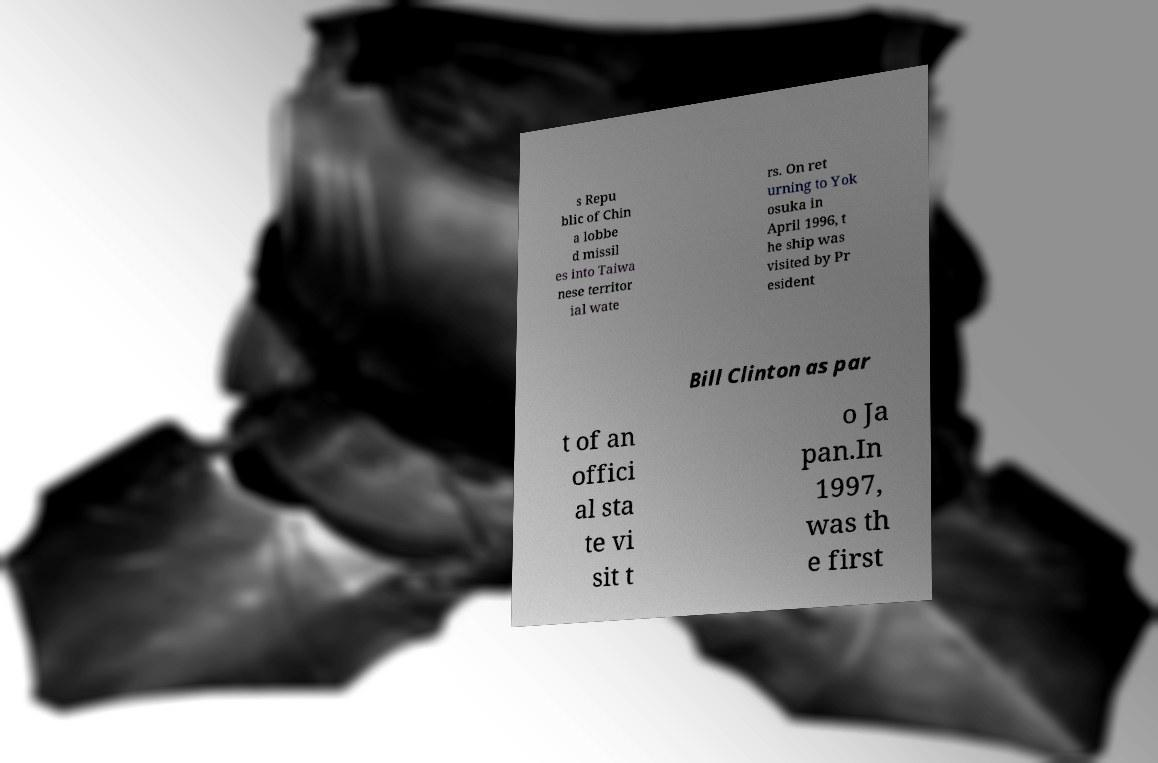For documentation purposes, I need the text within this image transcribed. Could you provide that? s Repu blic of Chin a lobbe d missil es into Taiwa nese territor ial wate rs. On ret urning to Yok osuka in April 1996, t he ship was visited by Pr esident Bill Clinton as par t of an offici al sta te vi sit t o Ja pan.In 1997, was th e first 